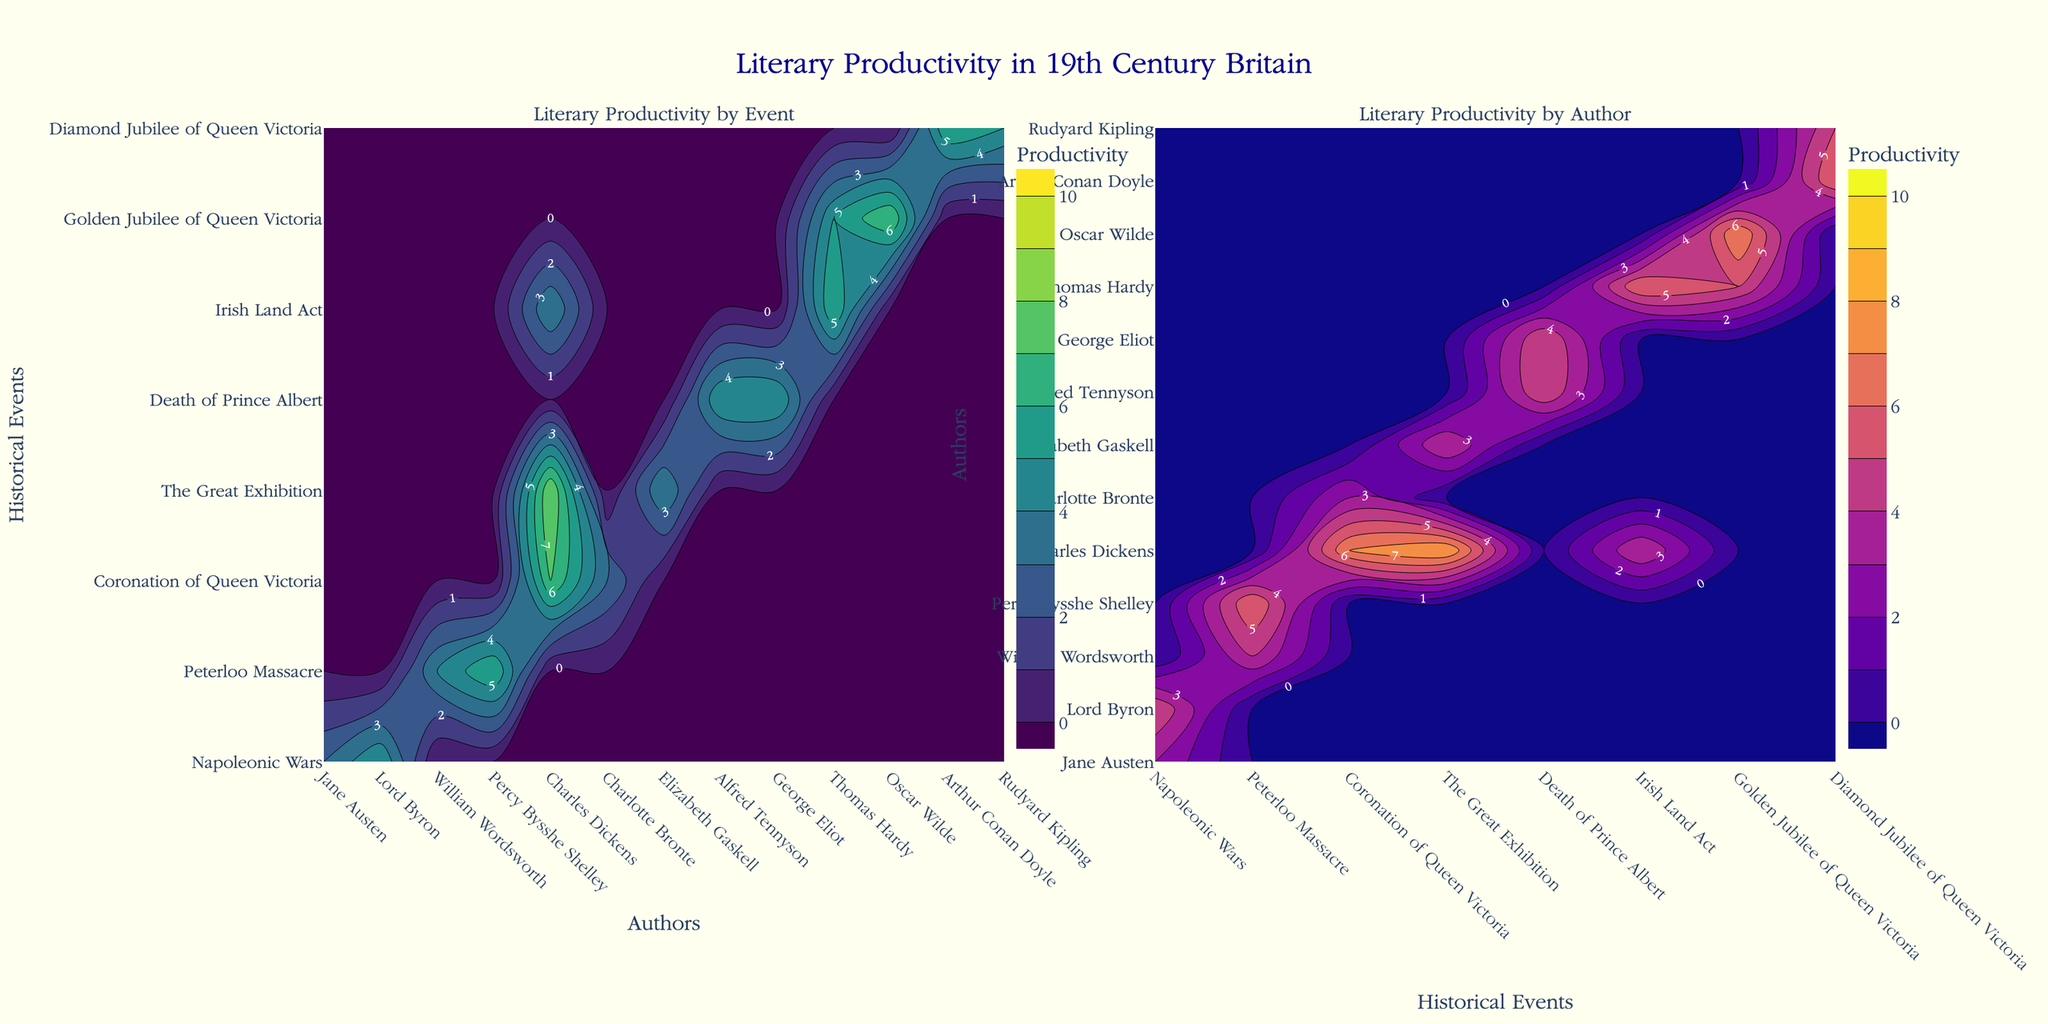What is the title of the plot? The plot title is located at the top center of the figure. It provides an overview of what the figure represents, which in this case is "Literary Productivity in 19th Century Britain".
Answer: Literary Productivity in 19th Century Britain How many historical events are listed in the first contour plot? To determine the number of historical events, observe the y-axis of the first contour plot labeled "Literary Productivity by Event". Count the unique event labels along this axis.
Answer: 8 Who is the author with the highest literary productivity during the "Golden Jubilee of Queen Victoria" in the second contour plot? Examine the contours for "Golden Jubilee of Queen Victoria" on the x-axis in the second plot ("Literary Productivity by Author"). Identify the author with the highest contour value around this event. This author will be the one corresponding to the peak in contours.
Answer: Oscar Wilde Between the historical event of "Death of Prince Albert" and "Irish Land Act," which has a higher combined literary productivity according to the authors listed in the first contour plot? Sum the contour values along the y-axis for "Death of Prince Albert" and then for "Irish Land Act". Compare these sums to see which event has a higher total productivity.
Answer: Death of Prince Albert Compare the contours for Charles Dickens in both plots. How does his productivity vary across different historical events? Look at the contours corresponding to Charles Dickens in both plots. Note the peaks and values associated with historical events to describe the variations in his productivity across different events.
Answer: He has high productivity during "Coronation of Queen Victoria" and "The Great Exhibition", but lower during "Irish Land Act" Which historical event shows the lowest literary productivity for all authors combined in the first contour plot? Identify the contour that is closest to zero across all authors on the y-axis of the first contour plot. This represents the event with the overall lowest productivity.
Answer: Peterloo Massacre What color scale is used for representing productivity in the second contour plot? Observing the second contour plot, note the color gradient used to represent varying levels of productivity. The legend or the contour lines will typically show a unique color scheme.
Answer: Plasma In the second contour plot, which author has a productivity value of 5 for "Diamond Jubilee of Queen Victoria"? Check the contours for "Diamond Jubilee of Queen Victoria" along the x-axis. Identify where the value 5 is located and match it to the respective author along the y-axis.
Answer: Rudyard Kipling Which author shows the highest peak in literary productivity according to the first contour plot? Identify the highest contour value across all authors in the first contour plot. The author corresponding to this highest peak has the highest productivity.
Answer: Charles Dickens How does Alfred Tennyson's productivity compare during "Death of Prince Albert" and "Napoleonic Wars"? Locate the contours corresponding to Alfred Tennyson for both "Death of Prince Albert" and "Napoleonic Wars". Compare the contour values to see which is higher.
Answer: Higher during Death of Prince Albert 